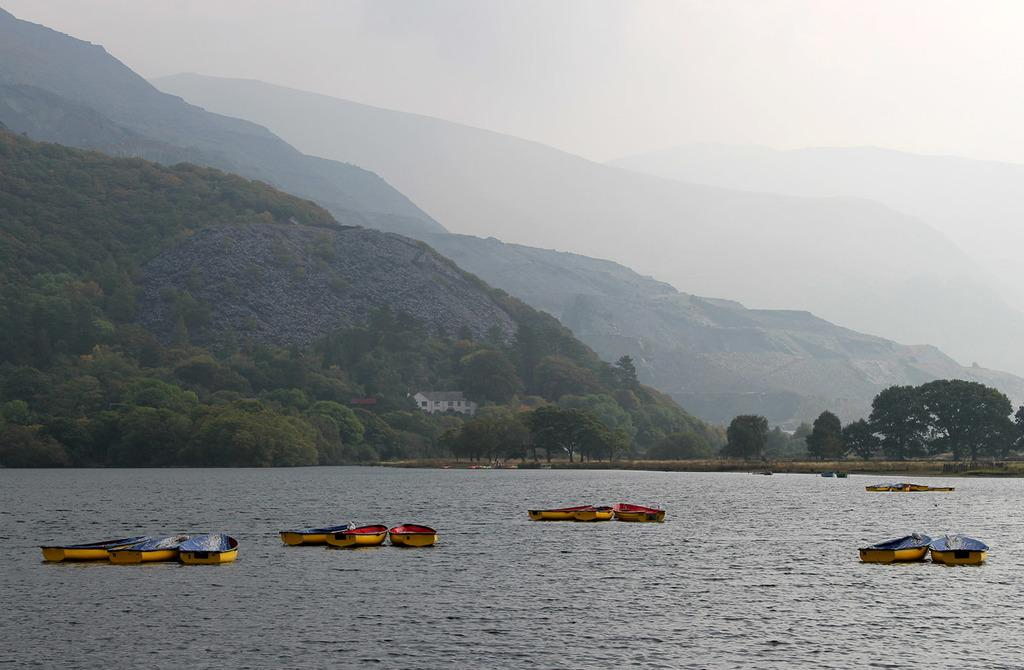What is in the water in the image? There are boats in the water in the image. What can be seen in the background of the image? Hills, trees, a house, and the sky are visible in the background of the image. How many different types of natural elements are present in the background? There are four different types of natural elements present in the background: hills, trees, a house, and the sky. Reasoning: Let' Let's think step by step in order to produce the conversation. We start by identifying the main subjects and objects in the image based on the provided facts. We then formulate questions that focus on the location and characteristics of these subjects and objects, ensuring that each question can be answered definitively with the information given. We avoid yes/no questions and ensure that the language is simple and clear. Absurd Question/Answer: Where is the cactus located in the image? There is no cactus present in the image. What type of mask is being worn by the trees in the image? There are no masks present in the image, as it features boats in the water and natural elements in the background. What type of caption is written on the boats in the image? There is no caption present on the boats in the image. The image features boats in the water and natural elements in the background, but no text or captions are visible. 